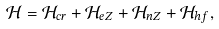<formula> <loc_0><loc_0><loc_500><loc_500>\mathcal { H } = \mathcal { H } _ { c r } + \mathcal { H } _ { e Z } + \mathcal { H } _ { n Z } + \mathcal { H } _ { h f } ,</formula> 